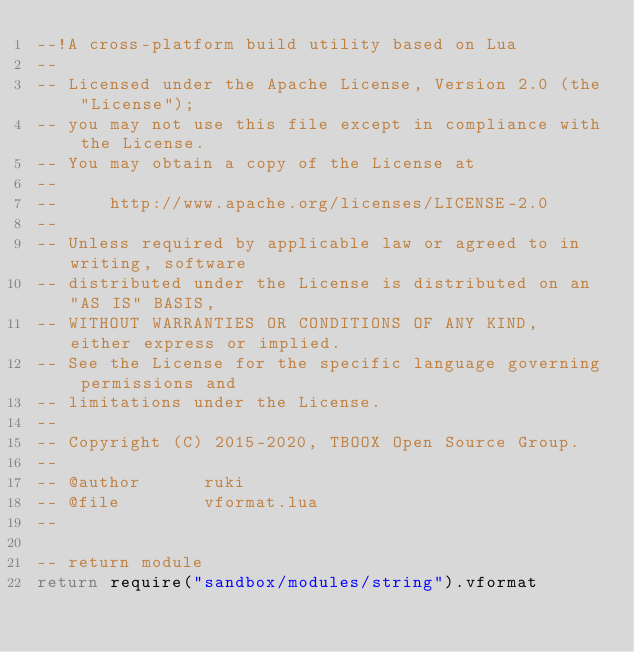Convert code to text. <code><loc_0><loc_0><loc_500><loc_500><_Lua_>--!A cross-platform build utility based on Lua
--
-- Licensed under the Apache License, Version 2.0 (the "License");
-- you may not use this file except in compliance with the License.
-- You may obtain a copy of the License at
--
--     http://www.apache.org/licenses/LICENSE-2.0
--
-- Unless required by applicable law or agreed to in writing, software
-- distributed under the License is distributed on an "AS IS" BASIS,
-- WITHOUT WARRANTIES OR CONDITIONS OF ANY KIND, either express or implied.
-- See the License for the specific language governing permissions and
-- limitations under the License.
-- 
-- Copyright (C) 2015-2020, TBOOX Open Source Group.
--
-- @author      ruki
-- @file        vformat.lua
--

-- return module
return require("sandbox/modules/string").vformat


</code> 